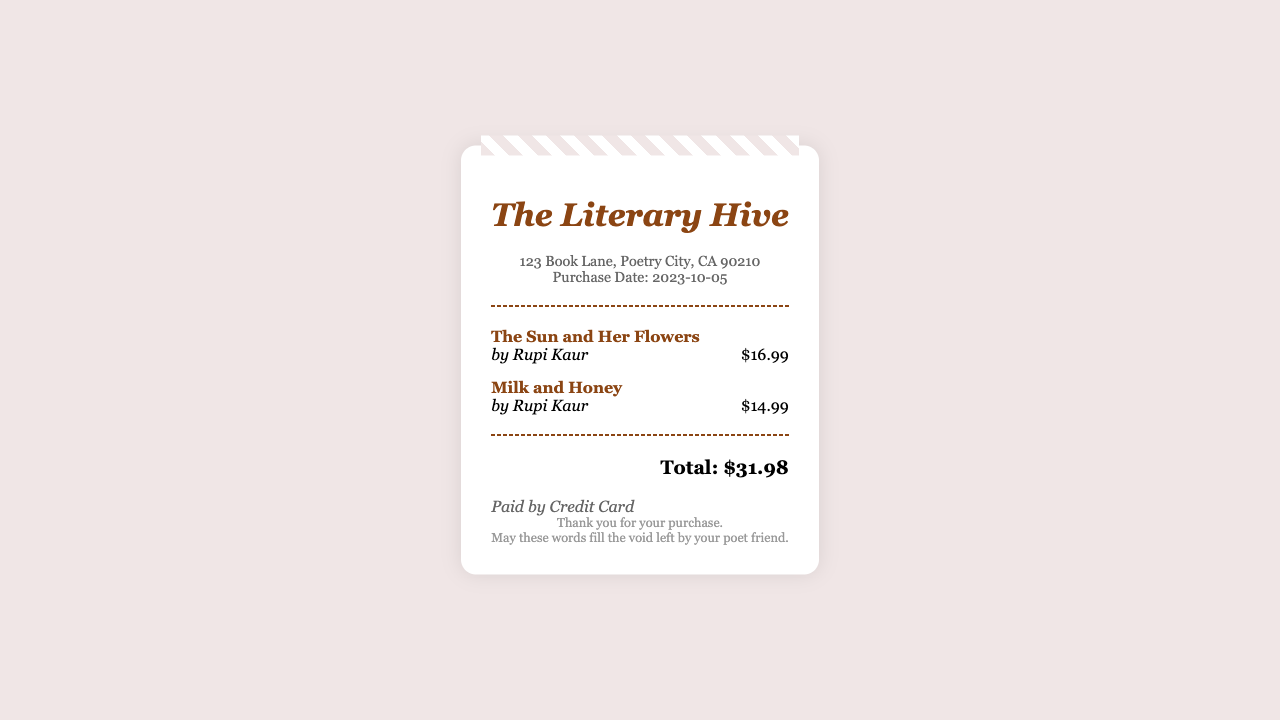What is the name of the store? The name of the store is presented at the top of the receipt.
Answer: The Literary Hive Who is the author of "The Sun and Her Flowers"? The author of the book is mentioned right below its title.
Answer: Rupi Kaur What is the total amount spent on the purchase? The total amount is clearly stated at the bottom of the receipt.
Answer: $31.98 When was the purchase made? The purchase date is noted in the store information section.
Answer: 2023-10-05 How many poetry books were purchased? The number of items listed in the receipt indicates the count of purchased books.
Answer: 2 What is the price of "Milk and Honey"? The price of the book is displayed next to its title on the receipt.
Answer: $14.99 What payment method was used? The payment method is specified in a dedicated section of the receipt.
Answer: Credit Card What message is conveyed in the footer? The footer includes a closing sentiment for the customer regarding their purchase.
Answer: May these words fill the void left by your poet friend 